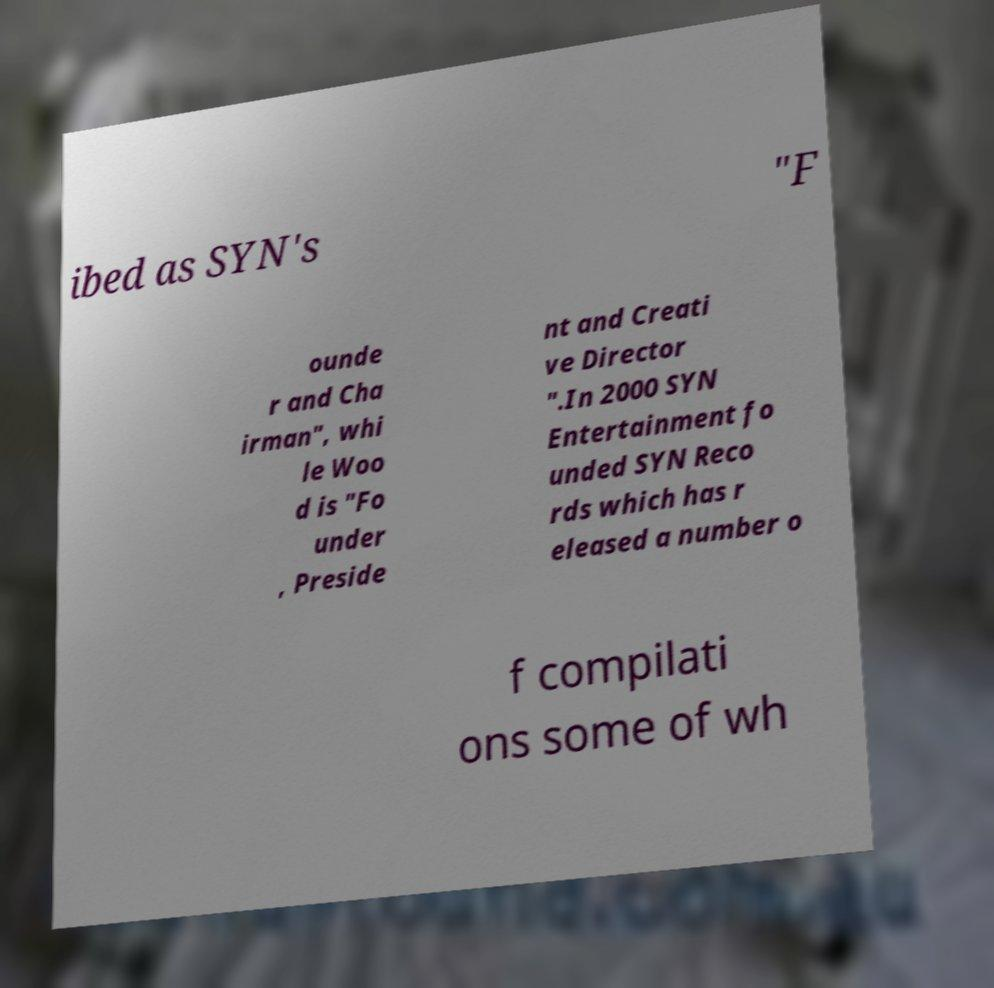Can you accurately transcribe the text from the provided image for me? ibed as SYN's "F ounde r and Cha irman", whi le Woo d is "Fo under , Preside nt and Creati ve Director ".In 2000 SYN Entertainment fo unded SYN Reco rds which has r eleased a number o f compilati ons some of wh 